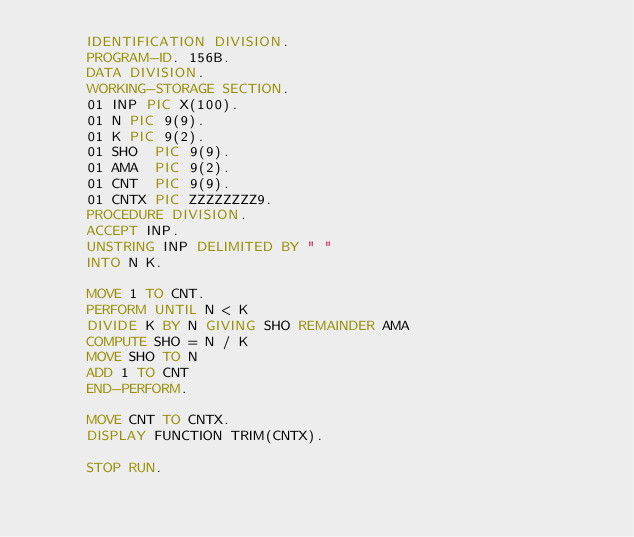<code> <loc_0><loc_0><loc_500><loc_500><_COBOL_>      IDENTIFICATION DIVISION.
      PROGRAM-ID. 156B.
      DATA DIVISION.
      WORKING-STORAGE SECTION.
      01 INP PIC X(100).
      01 N PIC 9(9).
      01 K PIC 9(2).
      01 SHO  PIC 9(9).
      01 AMA  PIC 9(2).
      01 CNT  PIC 9(9).
      01 CNTX PIC ZZZZZZZZ9.
      PROCEDURE DIVISION.
      ACCEPT INP.
      UNSTRING INP DELIMITED BY " "
      INTO N K.
            
      MOVE 1 TO CNT.
      PERFORM UNTIL N < K
      DIVIDE K BY N GIVING SHO REMAINDER AMA
      COMPUTE SHO = N / K
      MOVE SHO TO N
      ADD 1 TO CNT
      END-PERFORM.
      
      MOVE CNT TO CNTX.
      DISPLAY FUNCTION TRIM(CNTX).
      
      STOP RUN.
      
</code> 